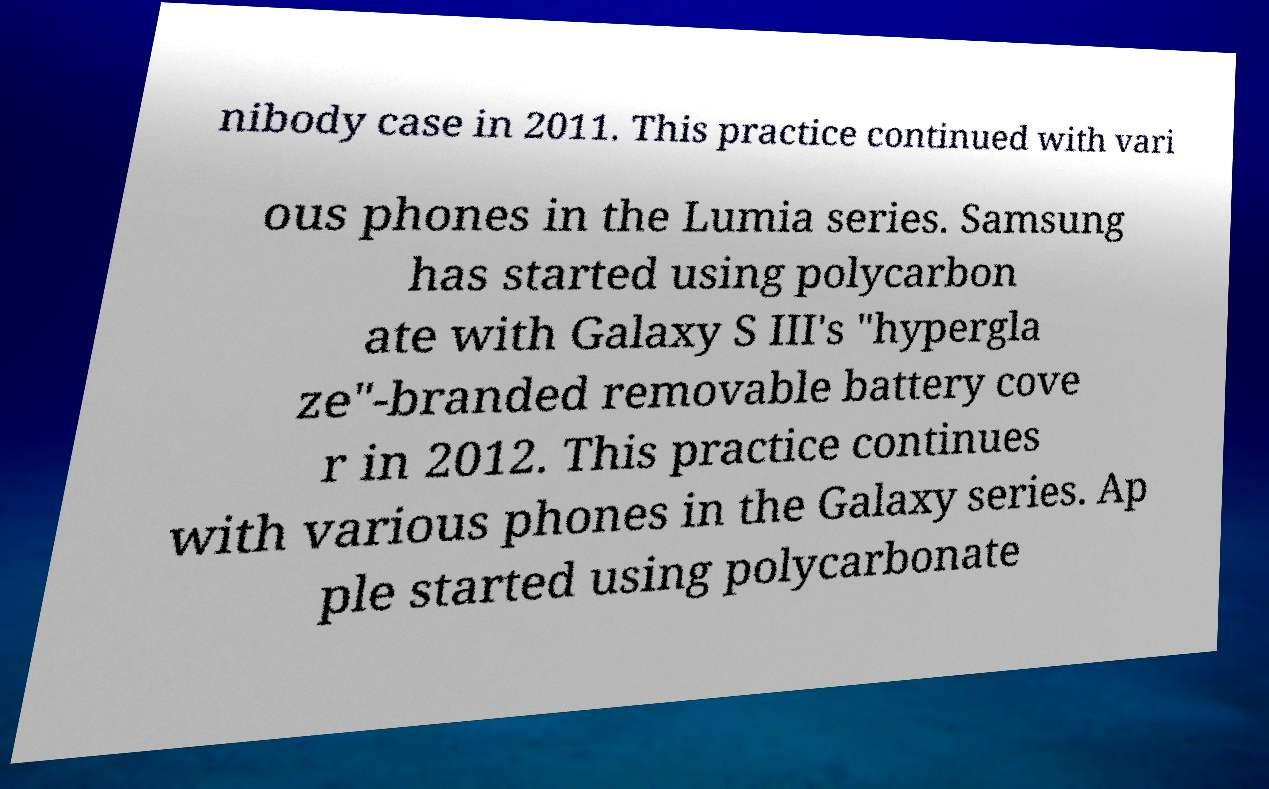Can you read and provide the text displayed in the image?This photo seems to have some interesting text. Can you extract and type it out for me? nibody case in 2011. This practice continued with vari ous phones in the Lumia series. Samsung has started using polycarbon ate with Galaxy S III's "hypergla ze"-branded removable battery cove r in 2012. This practice continues with various phones in the Galaxy series. Ap ple started using polycarbonate 